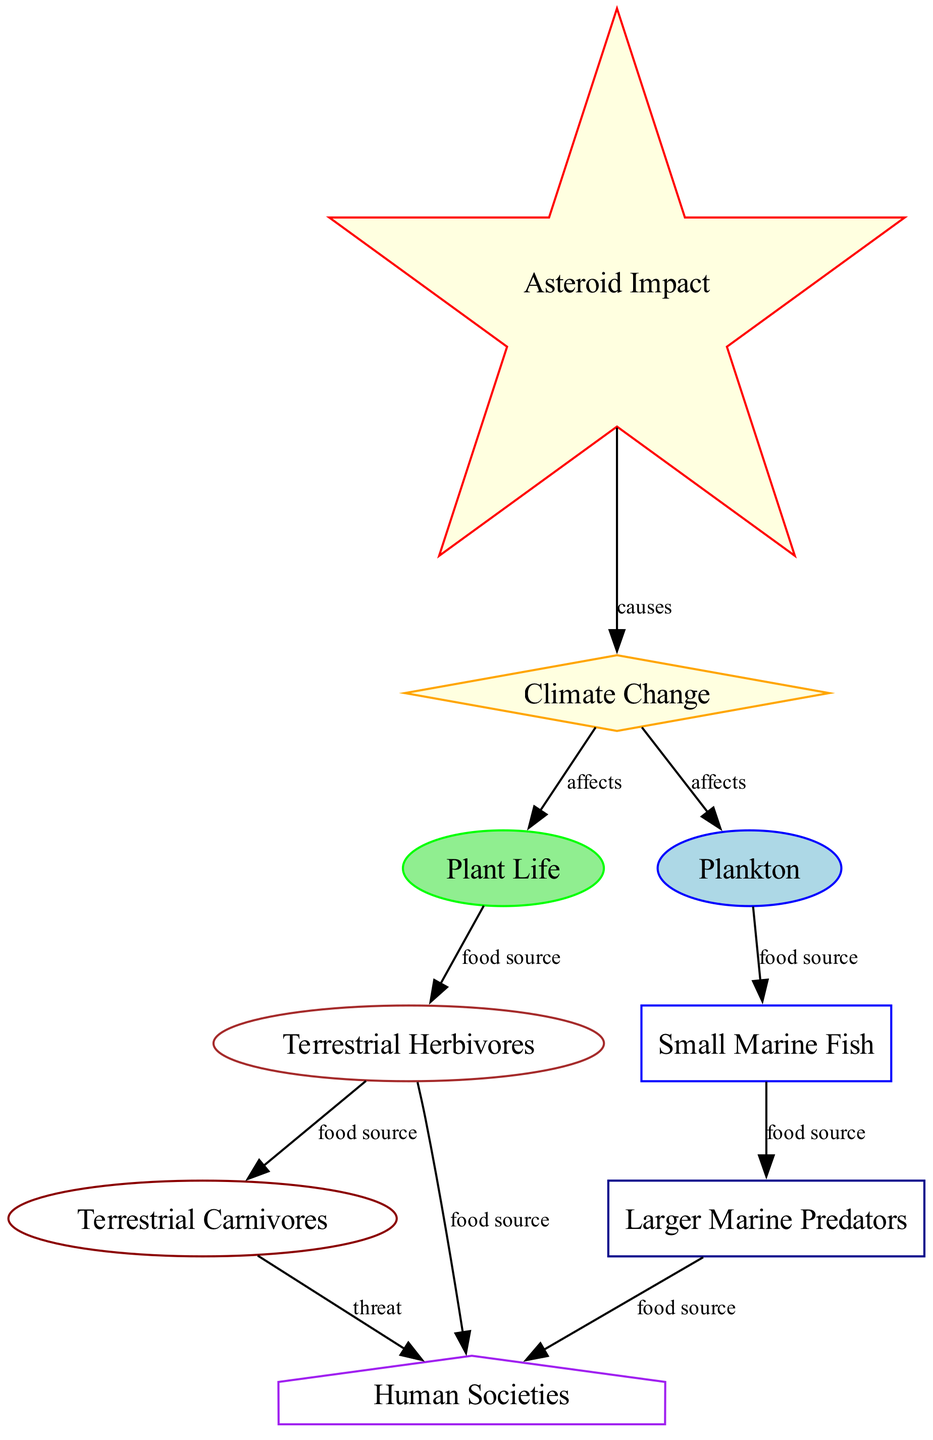What is the total number of nodes in the diagram? The diagram includes nodes representing various elements of the food chain and impact factors, specifically 9 distinct nodes such as asteroid impact, climate change, plant life, plankton, and others.
Answer: 9 How many edges are connecting the nodes? By counting the connections in the diagram between nodes and their related impacts or relationships, there are 10 edges that illustrate these connections.
Answer: 10 What do climate change and plant life have in common? Both climate change and plant life are connected in the diagram, specifically climate change affects plant life, indicating a direct impact on the vegetation required for terrestrial herbivores.
Answer: Affects Which node is the primary source of energy for terrestrial herbivores? The diagram indicates that plant life serves as the main food source for terrestrial herbivores, highlighting the role of plants in supporting these animals.
Answer: Plant Life What is the relationship between larger marine predators and human societies? The diagram states that larger marine predators are a food source for human societies, showing the direct consumption of these predators by humans.
Answer: Food source How does asteroid impact affect the food chain? Asteroid impact initiates a sequence that leads to climate change, which subsequently affects both plant life and plankton, indicating that the food chain is directly influenced by the occurrence of asteroid impacts.
Answer: Causes Which organisms are impacted by climate change according to the diagram? According to the diagram, climate change impacts both plant life and plankton, affecting the base of the food chain first before influencing higher trophic levels.
Answer: Plant Life and Plankton Identify a node that is both a source and a threat to human societies. The diagram shows that terrestrial carnivores provide a food source but also pose a threat to human societies, representing a dual impact on humans in terms of sustenance and danger.
Answer: Terrestrial Carnivores What is the final energy consumer in this food chain? Human societies are depicted in the diagram as the final energy consumers, receiving food sources from both terrestrial herbivores and larger marine predators, culminating the food chain.
Answer: Human Societies 